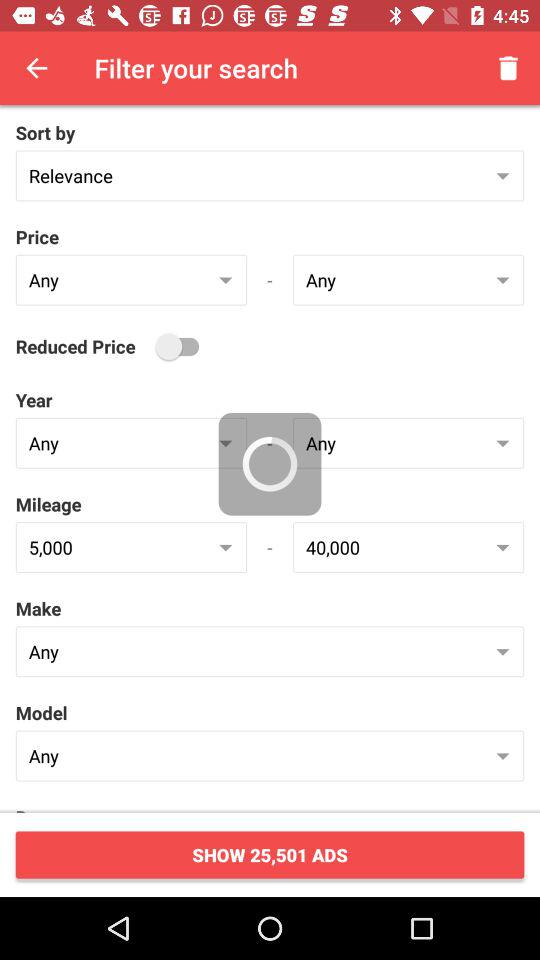What is the minimum mileage?
When the provided information is insufficient, respond with <no answer>. <no answer> 